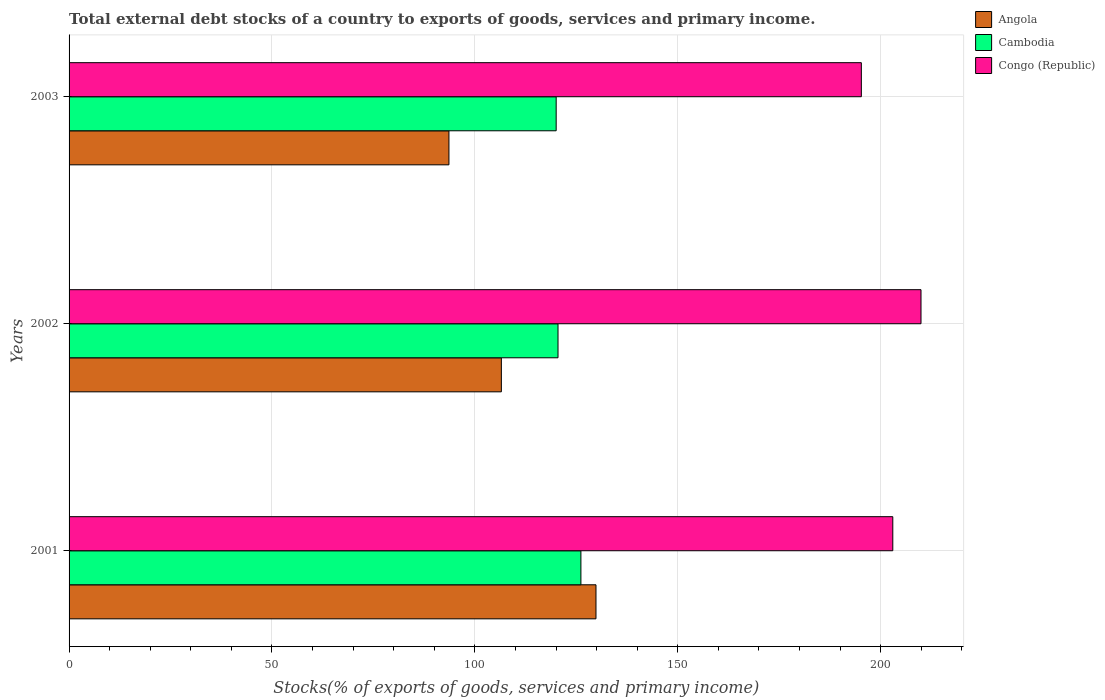Are the number of bars on each tick of the Y-axis equal?
Keep it short and to the point. Yes. What is the label of the 2nd group of bars from the top?
Provide a short and direct response. 2002. In how many cases, is the number of bars for a given year not equal to the number of legend labels?
Make the answer very short. 0. What is the total debt stocks in Congo (Republic) in 2002?
Your response must be concise. 209.93. Across all years, what is the maximum total debt stocks in Angola?
Make the answer very short. 129.84. Across all years, what is the minimum total debt stocks in Congo (Republic)?
Offer a terse response. 195.23. In which year was the total debt stocks in Angola maximum?
Provide a short and direct response. 2001. In which year was the total debt stocks in Congo (Republic) minimum?
Your answer should be compact. 2003. What is the total total debt stocks in Angola in the graph?
Your answer should be very brief. 329.97. What is the difference between the total debt stocks in Cambodia in 2001 and that in 2003?
Ensure brevity in your answer.  6.1. What is the difference between the total debt stocks in Congo (Republic) in 2001 and the total debt stocks in Cambodia in 2003?
Your answer should be compact. 82.95. What is the average total debt stocks in Cambodia per year?
Provide a short and direct response. 122.21. In the year 2001, what is the difference between the total debt stocks in Angola and total debt stocks in Cambodia?
Make the answer very short. 3.71. What is the ratio of the total debt stocks in Angola in 2001 to that in 2002?
Provide a succinct answer. 1.22. Is the total debt stocks in Angola in 2001 less than that in 2002?
Ensure brevity in your answer.  No. Is the difference between the total debt stocks in Angola in 2001 and 2002 greater than the difference between the total debt stocks in Cambodia in 2001 and 2002?
Provide a succinct answer. Yes. What is the difference between the highest and the second highest total debt stocks in Cambodia?
Make the answer very short. 5.64. What is the difference between the highest and the lowest total debt stocks in Angola?
Your answer should be compact. 36.23. In how many years, is the total debt stocks in Angola greater than the average total debt stocks in Angola taken over all years?
Provide a short and direct response. 1. What does the 1st bar from the top in 2002 represents?
Provide a succinct answer. Congo (Republic). What does the 3rd bar from the bottom in 2002 represents?
Your response must be concise. Congo (Republic). Are all the bars in the graph horizontal?
Your response must be concise. Yes. How many years are there in the graph?
Provide a short and direct response. 3. Are the values on the major ticks of X-axis written in scientific E-notation?
Provide a short and direct response. No. Does the graph contain any zero values?
Offer a terse response. No. Does the graph contain grids?
Provide a short and direct response. Yes. Where does the legend appear in the graph?
Keep it short and to the point. Top right. How many legend labels are there?
Provide a short and direct response. 3. What is the title of the graph?
Provide a short and direct response. Total external debt stocks of a country to exports of goods, services and primary income. Does "World" appear as one of the legend labels in the graph?
Ensure brevity in your answer.  No. What is the label or title of the X-axis?
Your answer should be very brief. Stocks(% of exports of goods, services and primary income). What is the Stocks(% of exports of goods, services and primary income) in Angola in 2001?
Your answer should be very brief. 129.84. What is the Stocks(% of exports of goods, services and primary income) of Cambodia in 2001?
Offer a very short reply. 126.13. What is the Stocks(% of exports of goods, services and primary income) in Congo (Republic) in 2001?
Provide a short and direct response. 202.98. What is the Stocks(% of exports of goods, services and primary income) of Angola in 2002?
Your answer should be very brief. 106.52. What is the Stocks(% of exports of goods, services and primary income) of Cambodia in 2002?
Provide a short and direct response. 120.48. What is the Stocks(% of exports of goods, services and primary income) of Congo (Republic) in 2002?
Give a very brief answer. 209.93. What is the Stocks(% of exports of goods, services and primary income) in Angola in 2003?
Keep it short and to the point. 93.61. What is the Stocks(% of exports of goods, services and primary income) in Cambodia in 2003?
Give a very brief answer. 120.03. What is the Stocks(% of exports of goods, services and primary income) of Congo (Republic) in 2003?
Your answer should be compact. 195.23. Across all years, what is the maximum Stocks(% of exports of goods, services and primary income) of Angola?
Provide a succinct answer. 129.84. Across all years, what is the maximum Stocks(% of exports of goods, services and primary income) in Cambodia?
Provide a succinct answer. 126.13. Across all years, what is the maximum Stocks(% of exports of goods, services and primary income) in Congo (Republic)?
Provide a succinct answer. 209.93. Across all years, what is the minimum Stocks(% of exports of goods, services and primary income) of Angola?
Provide a short and direct response. 93.61. Across all years, what is the minimum Stocks(% of exports of goods, services and primary income) of Cambodia?
Provide a succinct answer. 120.03. Across all years, what is the minimum Stocks(% of exports of goods, services and primary income) in Congo (Republic)?
Provide a succinct answer. 195.23. What is the total Stocks(% of exports of goods, services and primary income) of Angola in the graph?
Provide a short and direct response. 329.97. What is the total Stocks(% of exports of goods, services and primary income) of Cambodia in the graph?
Ensure brevity in your answer.  366.64. What is the total Stocks(% of exports of goods, services and primary income) of Congo (Republic) in the graph?
Keep it short and to the point. 608.14. What is the difference between the Stocks(% of exports of goods, services and primary income) of Angola in 2001 and that in 2002?
Make the answer very short. 23.32. What is the difference between the Stocks(% of exports of goods, services and primary income) in Cambodia in 2001 and that in 2002?
Give a very brief answer. 5.64. What is the difference between the Stocks(% of exports of goods, services and primary income) of Congo (Republic) in 2001 and that in 2002?
Give a very brief answer. -6.95. What is the difference between the Stocks(% of exports of goods, services and primary income) in Angola in 2001 and that in 2003?
Give a very brief answer. 36.23. What is the difference between the Stocks(% of exports of goods, services and primary income) in Cambodia in 2001 and that in 2003?
Provide a succinct answer. 6.1. What is the difference between the Stocks(% of exports of goods, services and primary income) of Congo (Republic) in 2001 and that in 2003?
Your response must be concise. 7.75. What is the difference between the Stocks(% of exports of goods, services and primary income) in Angola in 2002 and that in 2003?
Your answer should be very brief. 12.92. What is the difference between the Stocks(% of exports of goods, services and primary income) in Cambodia in 2002 and that in 2003?
Your response must be concise. 0.46. What is the difference between the Stocks(% of exports of goods, services and primary income) in Congo (Republic) in 2002 and that in 2003?
Your response must be concise. 14.7. What is the difference between the Stocks(% of exports of goods, services and primary income) in Angola in 2001 and the Stocks(% of exports of goods, services and primary income) in Cambodia in 2002?
Your answer should be compact. 9.36. What is the difference between the Stocks(% of exports of goods, services and primary income) in Angola in 2001 and the Stocks(% of exports of goods, services and primary income) in Congo (Republic) in 2002?
Ensure brevity in your answer.  -80.09. What is the difference between the Stocks(% of exports of goods, services and primary income) in Cambodia in 2001 and the Stocks(% of exports of goods, services and primary income) in Congo (Republic) in 2002?
Provide a succinct answer. -83.8. What is the difference between the Stocks(% of exports of goods, services and primary income) in Angola in 2001 and the Stocks(% of exports of goods, services and primary income) in Cambodia in 2003?
Your answer should be compact. 9.81. What is the difference between the Stocks(% of exports of goods, services and primary income) of Angola in 2001 and the Stocks(% of exports of goods, services and primary income) of Congo (Republic) in 2003?
Provide a short and direct response. -65.39. What is the difference between the Stocks(% of exports of goods, services and primary income) of Cambodia in 2001 and the Stocks(% of exports of goods, services and primary income) of Congo (Republic) in 2003?
Your answer should be compact. -69.1. What is the difference between the Stocks(% of exports of goods, services and primary income) in Angola in 2002 and the Stocks(% of exports of goods, services and primary income) in Cambodia in 2003?
Provide a short and direct response. -13.5. What is the difference between the Stocks(% of exports of goods, services and primary income) of Angola in 2002 and the Stocks(% of exports of goods, services and primary income) of Congo (Republic) in 2003?
Keep it short and to the point. -88.7. What is the difference between the Stocks(% of exports of goods, services and primary income) of Cambodia in 2002 and the Stocks(% of exports of goods, services and primary income) of Congo (Republic) in 2003?
Offer a very short reply. -74.74. What is the average Stocks(% of exports of goods, services and primary income) of Angola per year?
Provide a succinct answer. 109.99. What is the average Stocks(% of exports of goods, services and primary income) in Cambodia per year?
Provide a succinct answer. 122.21. What is the average Stocks(% of exports of goods, services and primary income) of Congo (Republic) per year?
Your response must be concise. 202.71. In the year 2001, what is the difference between the Stocks(% of exports of goods, services and primary income) of Angola and Stocks(% of exports of goods, services and primary income) of Cambodia?
Make the answer very short. 3.71. In the year 2001, what is the difference between the Stocks(% of exports of goods, services and primary income) in Angola and Stocks(% of exports of goods, services and primary income) in Congo (Republic)?
Provide a short and direct response. -73.14. In the year 2001, what is the difference between the Stocks(% of exports of goods, services and primary income) of Cambodia and Stocks(% of exports of goods, services and primary income) of Congo (Republic)?
Give a very brief answer. -76.85. In the year 2002, what is the difference between the Stocks(% of exports of goods, services and primary income) in Angola and Stocks(% of exports of goods, services and primary income) in Cambodia?
Your response must be concise. -13.96. In the year 2002, what is the difference between the Stocks(% of exports of goods, services and primary income) of Angola and Stocks(% of exports of goods, services and primary income) of Congo (Republic)?
Your answer should be compact. -103.41. In the year 2002, what is the difference between the Stocks(% of exports of goods, services and primary income) of Cambodia and Stocks(% of exports of goods, services and primary income) of Congo (Republic)?
Provide a short and direct response. -89.45. In the year 2003, what is the difference between the Stocks(% of exports of goods, services and primary income) of Angola and Stocks(% of exports of goods, services and primary income) of Cambodia?
Offer a very short reply. -26.42. In the year 2003, what is the difference between the Stocks(% of exports of goods, services and primary income) in Angola and Stocks(% of exports of goods, services and primary income) in Congo (Republic)?
Ensure brevity in your answer.  -101.62. In the year 2003, what is the difference between the Stocks(% of exports of goods, services and primary income) in Cambodia and Stocks(% of exports of goods, services and primary income) in Congo (Republic)?
Make the answer very short. -75.2. What is the ratio of the Stocks(% of exports of goods, services and primary income) in Angola in 2001 to that in 2002?
Your response must be concise. 1.22. What is the ratio of the Stocks(% of exports of goods, services and primary income) in Cambodia in 2001 to that in 2002?
Ensure brevity in your answer.  1.05. What is the ratio of the Stocks(% of exports of goods, services and primary income) in Congo (Republic) in 2001 to that in 2002?
Make the answer very short. 0.97. What is the ratio of the Stocks(% of exports of goods, services and primary income) of Angola in 2001 to that in 2003?
Offer a terse response. 1.39. What is the ratio of the Stocks(% of exports of goods, services and primary income) of Cambodia in 2001 to that in 2003?
Your answer should be compact. 1.05. What is the ratio of the Stocks(% of exports of goods, services and primary income) of Congo (Republic) in 2001 to that in 2003?
Your response must be concise. 1.04. What is the ratio of the Stocks(% of exports of goods, services and primary income) in Angola in 2002 to that in 2003?
Make the answer very short. 1.14. What is the ratio of the Stocks(% of exports of goods, services and primary income) in Congo (Republic) in 2002 to that in 2003?
Keep it short and to the point. 1.08. What is the difference between the highest and the second highest Stocks(% of exports of goods, services and primary income) of Angola?
Provide a short and direct response. 23.32. What is the difference between the highest and the second highest Stocks(% of exports of goods, services and primary income) of Cambodia?
Offer a terse response. 5.64. What is the difference between the highest and the second highest Stocks(% of exports of goods, services and primary income) in Congo (Republic)?
Offer a very short reply. 6.95. What is the difference between the highest and the lowest Stocks(% of exports of goods, services and primary income) in Angola?
Give a very brief answer. 36.23. What is the difference between the highest and the lowest Stocks(% of exports of goods, services and primary income) of Cambodia?
Give a very brief answer. 6.1. What is the difference between the highest and the lowest Stocks(% of exports of goods, services and primary income) in Congo (Republic)?
Provide a succinct answer. 14.7. 